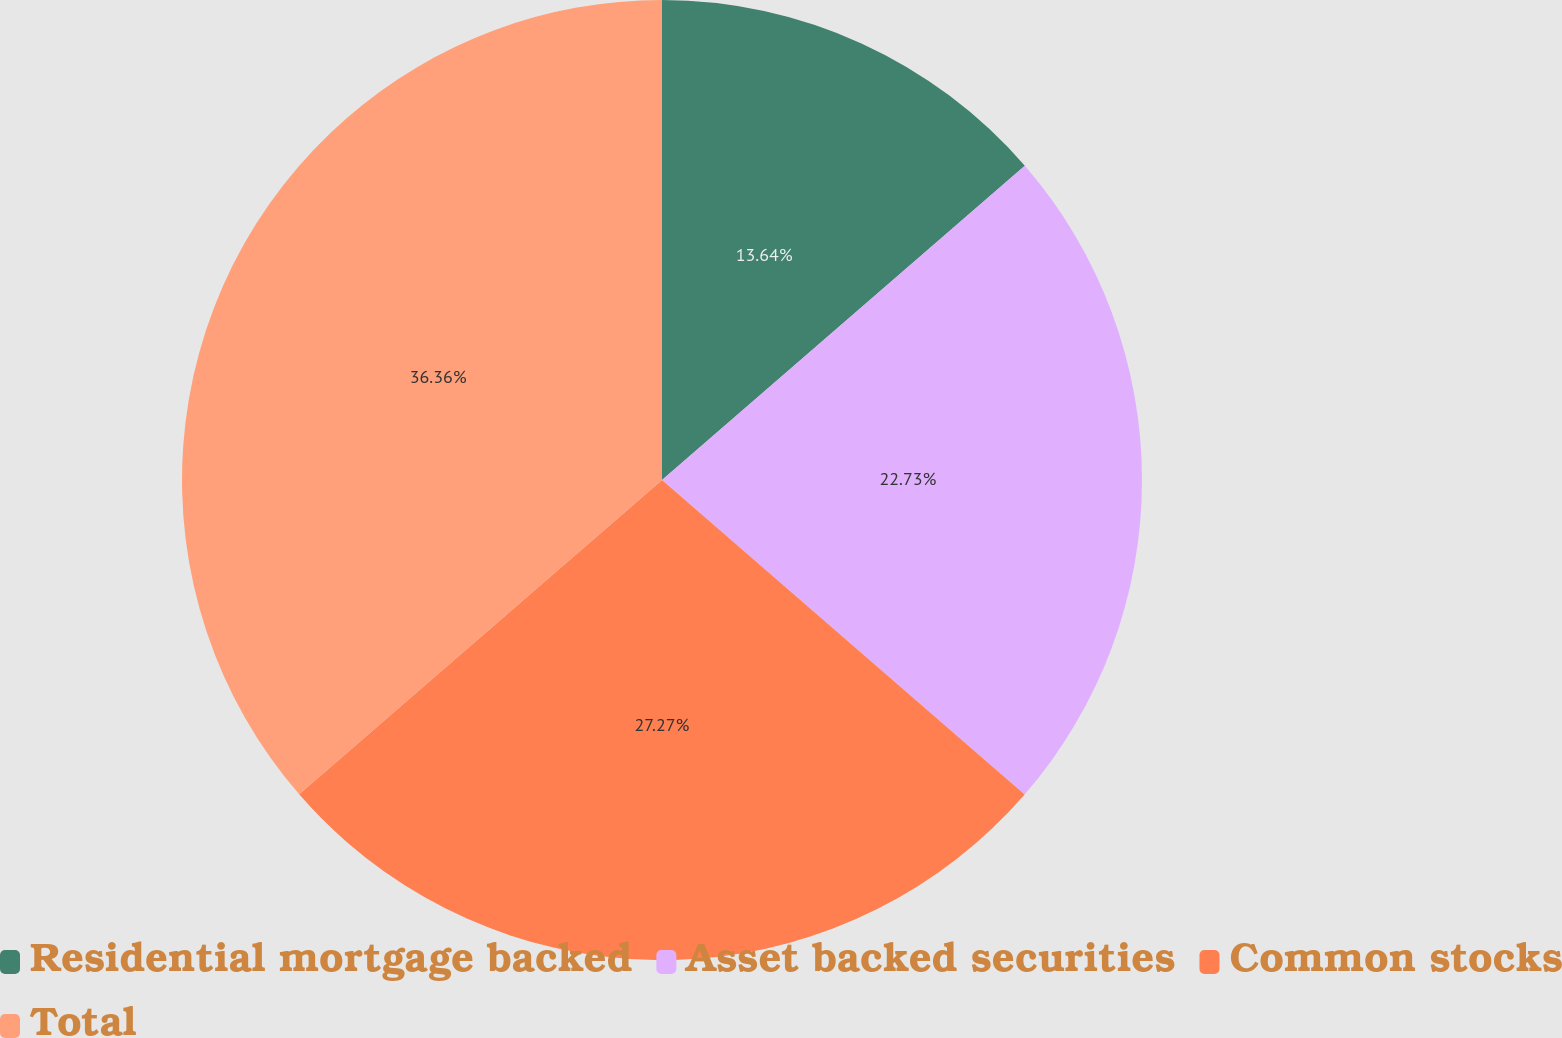<chart> <loc_0><loc_0><loc_500><loc_500><pie_chart><fcel>Residential mortgage backed<fcel>Asset backed securities<fcel>Common stocks<fcel>Total<nl><fcel>13.64%<fcel>22.73%<fcel>27.27%<fcel>36.36%<nl></chart> 